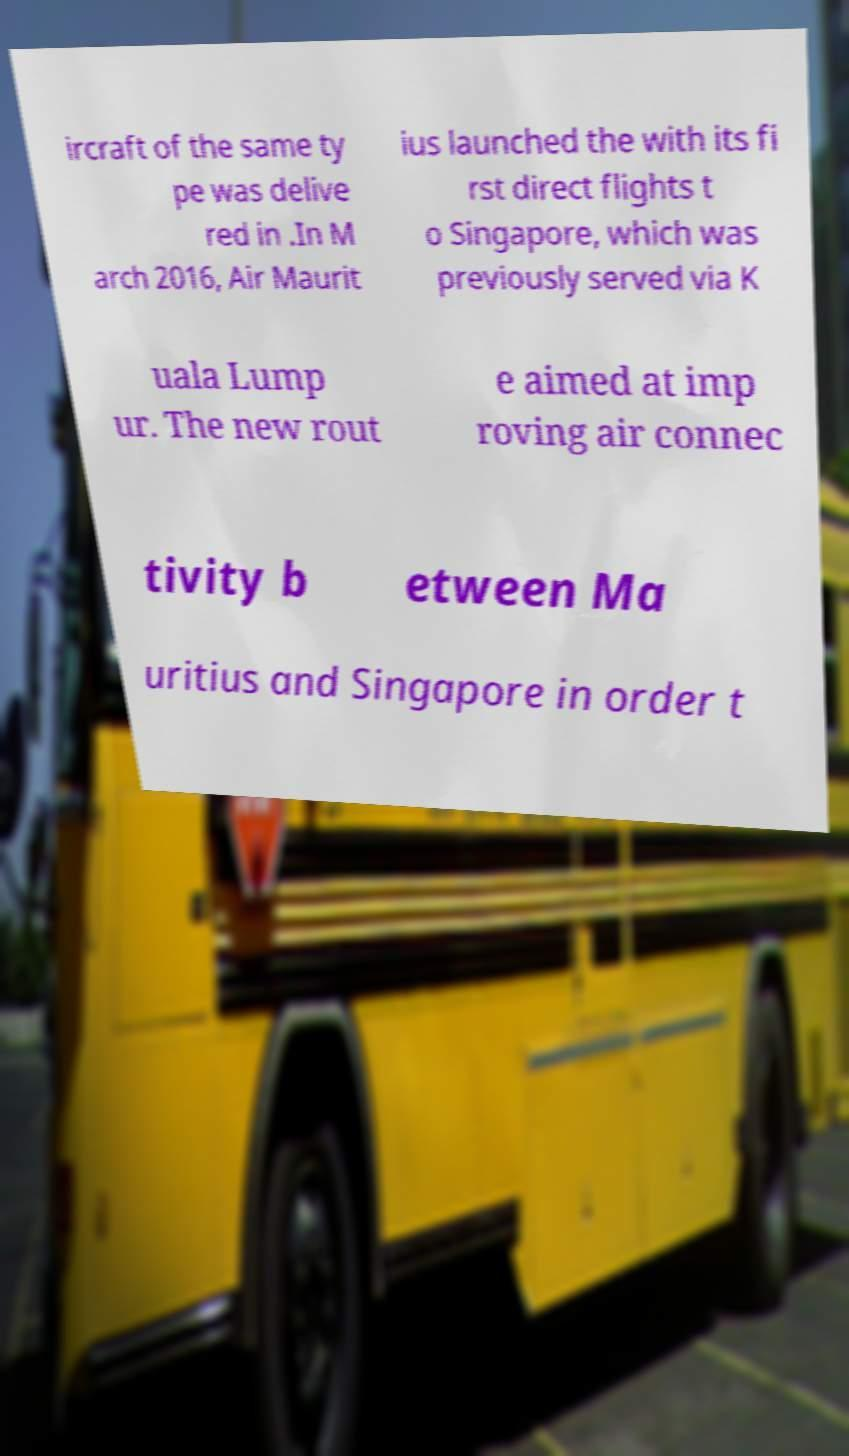Can you accurately transcribe the text from the provided image for me? ircraft of the same ty pe was delive red in .In M arch 2016, Air Maurit ius launched the with its fi rst direct flights t o Singapore, which was previously served via K uala Lump ur. The new rout e aimed at imp roving air connec tivity b etween Ma uritius and Singapore in order t 